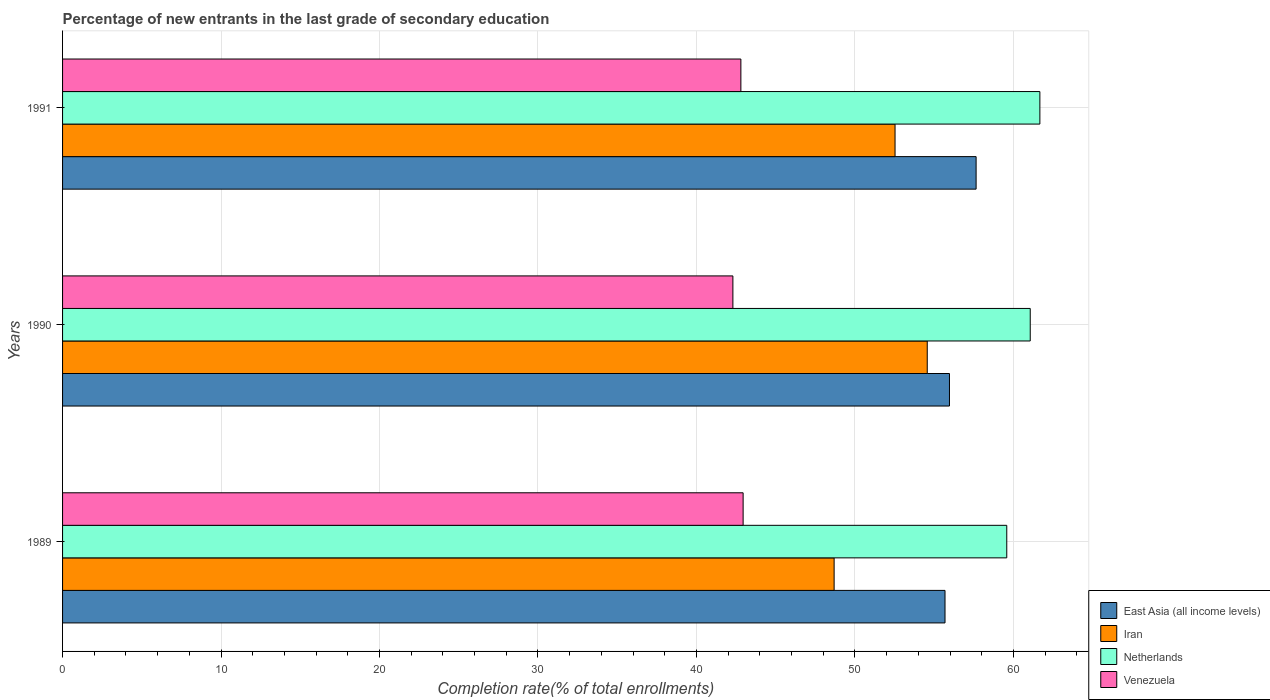How many groups of bars are there?
Your answer should be compact. 3. Are the number of bars per tick equal to the number of legend labels?
Make the answer very short. Yes. How many bars are there on the 3rd tick from the top?
Your answer should be compact. 4. How many bars are there on the 2nd tick from the bottom?
Keep it short and to the point. 4. In how many cases, is the number of bars for a given year not equal to the number of legend labels?
Offer a very short reply. 0. What is the percentage of new entrants in Iran in 1990?
Your answer should be compact. 54.56. Across all years, what is the maximum percentage of new entrants in Netherlands?
Your response must be concise. 61.67. Across all years, what is the minimum percentage of new entrants in Netherlands?
Keep it short and to the point. 59.58. In which year was the percentage of new entrants in Netherlands maximum?
Your answer should be compact. 1991. In which year was the percentage of new entrants in Iran minimum?
Provide a short and direct response. 1989. What is the total percentage of new entrants in East Asia (all income levels) in the graph?
Ensure brevity in your answer.  169.3. What is the difference between the percentage of new entrants in Venezuela in 1989 and that in 1990?
Keep it short and to the point. 0.65. What is the difference between the percentage of new entrants in Netherlands in 1990 and the percentage of new entrants in Venezuela in 1989?
Give a very brief answer. 18.12. What is the average percentage of new entrants in East Asia (all income levels) per year?
Your response must be concise. 56.43. In the year 1990, what is the difference between the percentage of new entrants in Netherlands and percentage of new entrants in East Asia (all income levels)?
Your answer should be very brief. 5.1. In how many years, is the percentage of new entrants in Netherlands greater than 22 %?
Ensure brevity in your answer.  3. What is the ratio of the percentage of new entrants in Venezuela in 1989 to that in 1990?
Provide a succinct answer. 1.02. Is the difference between the percentage of new entrants in Netherlands in 1989 and 1990 greater than the difference between the percentage of new entrants in East Asia (all income levels) in 1989 and 1990?
Your answer should be very brief. No. What is the difference between the highest and the second highest percentage of new entrants in Netherlands?
Provide a succinct answer. 0.61. What is the difference between the highest and the lowest percentage of new entrants in Iran?
Ensure brevity in your answer.  5.88. What does the 3rd bar from the top in 1990 represents?
Give a very brief answer. Iran. What does the 1st bar from the bottom in 1991 represents?
Offer a very short reply. East Asia (all income levels). Is it the case that in every year, the sum of the percentage of new entrants in East Asia (all income levels) and percentage of new entrants in Netherlands is greater than the percentage of new entrants in Iran?
Provide a short and direct response. Yes. Are all the bars in the graph horizontal?
Provide a succinct answer. Yes. How many years are there in the graph?
Make the answer very short. 3. Are the values on the major ticks of X-axis written in scientific E-notation?
Offer a very short reply. No. How many legend labels are there?
Your answer should be very brief. 4. What is the title of the graph?
Your response must be concise. Percentage of new entrants in the last grade of secondary education. What is the label or title of the X-axis?
Provide a short and direct response. Completion rate(% of total enrollments). What is the Completion rate(% of total enrollments) of East Asia (all income levels) in 1989?
Ensure brevity in your answer.  55.68. What is the Completion rate(% of total enrollments) in Iran in 1989?
Provide a succinct answer. 48.69. What is the Completion rate(% of total enrollments) of Netherlands in 1989?
Offer a very short reply. 59.58. What is the Completion rate(% of total enrollments) in Venezuela in 1989?
Keep it short and to the point. 42.94. What is the Completion rate(% of total enrollments) in East Asia (all income levels) in 1990?
Your answer should be very brief. 55.97. What is the Completion rate(% of total enrollments) of Iran in 1990?
Offer a very short reply. 54.56. What is the Completion rate(% of total enrollments) of Netherlands in 1990?
Provide a short and direct response. 61.06. What is the Completion rate(% of total enrollments) in Venezuela in 1990?
Your response must be concise. 42.3. What is the Completion rate(% of total enrollments) of East Asia (all income levels) in 1991?
Give a very brief answer. 57.65. What is the Completion rate(% of total enrollments) of Iran in 1991?
Keep it short and to the point. 52.53. What is the Completion rate(% of total enrollments) in Netherlands in 1991?
Make the answer very short. 61.67. What is the Completion rate(% of total enrollments) of Venezuela in 1991?
Your response must be concise. 42.8. Across all years, what is the maximum Completion rate(% of total enrollments) in East Asia (all income levels)?
Your answer should be compact. 57.65. Across all years, what is the maximum Completion rate(% of total enrollments) of Iran?
Give a very brief answer. 54.56. Across all years, what is the maximum Completion rate(% of total enrollments) of Netherlands?
Offer a terse response. 61.67. Across all years, what is the maximum Completion rate(% of total enrollments) of Venezuela?
Give a very brief answer. 42.94. Across all years, what is the minimum Completion rate(% of total enrollments) in East Asia (all income levels)?
Your answer should be very brief. 55.68. Across all years, what is the minimum Completion rate(% of total enrollments) in Iran?
Provide a succinct answer. 48.69. Across all years, what is the minimum Completion rate(% of total enrollments) of Netherlands?
Give a very brief answer. 59.58. Across all years, what is the minimum Completion rate(% of total enrollments) in Venezuela?
Ensure brevity in your answer.  42.3. What is the total Completion rate(% of total enrollments) of East Asia (all income levels) in the graph?
Your answer should be very brief. 169.3. What is the total Completion rate(% of total enrollments) of Iran in the graph?
Ensure brevity in your answer.  155.78. What is the total Completion rate(% of total enrollments) in Netherlands in the graph?
Keep it short and to the point. 182.31. What is the total Completion rate(% of total enrollments) in Venezuela in the graph?
Your response must be concise. 128.05. What is the difference between the Completion rate(% of total enrollments) of East Asia (all income levels) in 1989 and that in 1990?
Provide a short and direct response. -0.28. What is the difference between the Completion rate(% of total enrollments) of Iran in 1989 and that in 1990?
Your response must be concise. -5.88. What is the difference between the Completion rate(% of total enrollments) in Netherlands in 1989 and that in 1990?
Provide a succinct answer. -1.48. What is the difference between the Completion rate(% of total enrollments) in Venezuela in 1989 and that in 1990?
Make the answer very short. 0.65. What is the difference between the Completion rate(% of total enrollments) of East Asia (all income levels) in 1989 and that in 1991?
Your answer should be very brief. -1.96. What is the difference between the Completion rate(% of total enrollments) in Iran in 1989 and that in 1991?
Give a very brief answer. -3.84. What is the difference between the Completion rate(% of total enrollments) of Netherlands in 1989 and that in 1991?
Offer a terse response. -2.09. What is the difference between the Completion rate(% of total enrollments) in Venezuela in 1989 and that in 1991?
Offer a very short reply. 0.14. What is the difference between the Completion rate(% of total enrollments) of East Asia (all income levels) in 1990 and that in 1991?
Give a very brief answer. -1.68. What is the difference between the Completion rate(% of total enrollments) of Iran in 1990 and that in 1991?
Provide a short and direct response. 2.03. What is the difference between the Completion rate(% of total enrollments) in Netherlands in 1990 and that in 1991?
Make the answer very short. -0.61. What is the difference between the Completion rate(% of total enrollments) of Venezuela in 1990 and that in 1991?
Ensure brevity in your answer.  -0.5. What is the difference between the Completion rate(% of total enrollments) of East Asia (all income levels) in 1989 and the Completion rate(% of total enrollments) of Iran in 1990?
Your answer should be compact. 1.12. What is the difference between the Completion rate(% of total enrollments) in East Asia (all income levels) in 1989 and the Completion rate(% of total enrollments) in Netherlands in 1990?
Your answer should be compact. -5.38. What is the difference between the Completion rate(% of total enrollments) of East Asia (all income levels) in 1989 and the Completion rate(% of total enrollments) of Venezuela in 1990?
Make the answer very short. 13.39. What is the difference between the Completion rate(% of total enrollments) of Iran in 1989 and the Completion rate(% of total enrollments) of Netherlands in 1990?
Offer a terse response. -12.37. What is the difference between the Completion rate(% of total enrollments) in Iran in 1989 and the Completion rate(% of total enrollments) in Venezuela in 1990?
Ensure brevity in your answer.  6.39. What is the difference between the Completion rate(% of total enrollments) in Netherlands in 1989 and the Completion rate(% of total enrollments) in Venezuela in 1990?
Your response must be concise. 17.28. What is the difference between the Completion rate(% of total enrollments) in East Asia (all income levels) in 1989 and the Completion rate(% of total enrollments) in Iran in 1991?
Give a very brief answer. 3.15. What is the difference between the Completion rate(% of total enrollments) in East Asia (all income levels) in 1989 and the Completion rate(% of total enrollments) in Netherlands in 1991?
Give a very brief answer. -5.99. What is the difference between the Completion rate(% of total enrollments) of East Asia (all income levels) in 1989 and the Completion rate(% of total enrollments) of Venezuela in 1991?
Offer a very short reply. 12.88. What is the difference between the Completion rate(% of total enrollments) of Iran in 1989 and the Completion rate(% of total enrollments) of Netherlands in 1991?
Provide a succinct answer. -12.98. What is the difference between the Completion rate(% of total enrollments) of Iran in 1989 and the Completion rate(% of total enrollments) of Venezuela in 1991?
Keep it short and to the point. 5.88. What is the difference between the Completion rate(% of total enrollments) in Netherlands in 1989 and the Completion rate(% of total enrollments) in Venezuela in 1991?
Offer a terse response. 16.78. What is the difference between the Completion rate(% of total enrollments) in East Asia (all income levels) in 1990 and the Completion rate(% of total enrollments) in Iran in 1991?
Offer a terse response. 3.43. What is the difference between the Completion rate(% of total enrollments) of East Asia (all income levels) in 1990 and the Completion rate(% of total enrollments) of Netherlands in 1991?
Offer a terse response. -5.71. What is the difference between the Completion rate(% of total enrollments) in East Asia (all income levels) in 1990 and the Completion rate(% of total enrollments) in Venezuela in 1991?
Keep it short and to the point. 13.16. What is the difference between the Completion rate(% of total enrollments) in Iran in 1990 and the Completion rate(% of total enrollments) in Netherlands in 1991?
Provide a short and direct response. -7.11. What is the difference between the Completion rate(% of total enrollments) in Iran in 1990 and the Completion rate(% of total enrollments) in Venezuela in 1991?
Offer a terse response. 11.76. What is the difference between the Completion rate(% of total enrollments) of Netherlands in 1990 and the Completion rate(% of total enrollments) of Venezuela in 1991?
Offer a very short reply. 18.26. What is the average Completion rate(% of total enrollments) in East Asia (all income levels) per year?
Give a very brief answer. 56.43. What is the average Completion rate(% of total enrollments) of Iran per year?
Offer a terse response. 51.93. What is the average Completion rate(% of total enrollments) in Netherlands per year?
Ensure brevity in your answer.  60.77. What is the average Completion rate(% of total enrollments) of Venezuela per year?
Your answer should be compact. 42.68. In the year 1989, what is the difference between the Completion rate(% of total enrollments) of East Asia (all income levels) and Completion rate(% of total enrollments) of Iran?
Keep it short and to the point. 7. In the year 1989, what is the difference between the Completion rate(% of total enrollments) in East Asia (all income levels) and Completion rate(% of total enrollments) in Netherlands?
Your answer should be compact. -3.9. In the year 1989, what is the difference between the Completion rate(% of total enrollments) of East Asia (all income levels) and Completion rate(% of total enrollments) of Venezuela?
Provide a short and direct response. 12.74. In the year 1989, what is the difference between the Completion rate(% of total enrollments) in Iran and Completion rate(% of total enrollments) in Netherlands?
Your answer should be very brief. -10.89. In the year 1989, what is the difference between the Completion rate(% of total enrollments) in Iran and Completion rate(% of total enrollments) in Venezuela?
Make the answer very short. 5.74. In the year 1989, what is the difference between the Completion rate(% of total enrollments) of Netherlands and Completion rate(% of total enrollments) of Venezuela?
Offer a terse response. 16.64. In the year 1990, what is the difference between the Completion rate(% of total enrollments) of East Asia (all income levels) and Completion rate(% of total enrollments) of Iran?
Ensure brevity in your answer.  1.4. In the year 1990, what is the difference between the Completion rate(% of total enrollments) of East Asia (all income levels) and Completion rate(% of total enrollments) of Netherlands?
Provide a short and direct response. -5.1. In the year 1990, what is the difference between the Completion rate(% of total enrollments) in East Asia (all income levels) and Completion rate(% of total enrollments) in Venezuela?
Make the answer very short. 13.67. In the year 1990, what is the difference between the Completion rate(% of total enrollments) of Iran and Completion rate(% of total enrollments) of Netherlands?
Offer a terse response. -6.5. In the year 1990, what is the difference between the Completion rate(% of total enrollments) in Iran and Completion rate(% of total enrollments) in Venezuela?
Your response must be concise. 12.26. In the year 1990, what is the difference between the Completion rate(% of total enrollments) in Netherlands and Completion rate(% of total enrollments) in Venezuela?
Your response must be concise. 18.76. In the year 1991, what is the difference between the Completion rate(% of total enrollments) in East Asia (all income levels) and Completion rate(% of total enrollments) in Iran?
Keep it short and to the point. 5.11. In the year 1991, what is the difference between the Completion rate(% of total enrollments) in East Asia (all income levels) and Completion rate(% of total enrollments) in Netherlands?
Ensure brevity in your answer.  -4.02. In the year 1991, what is the difference between the Completion rate(% of total enrollments) of East Asia (all income levels) and Completion rate(% of total enrollments) of Venezuela?
Your answer should be very brief. 14.84. In the year 1991, what is the difference between the Completion rate(% of total enrollments) of Iran and Completion rate(% of total enrollments) of Netherlands?
Offer a very short reply. -9.14. In the year 1991, what is the difference between the Completion rate(% of total enrollments) in Iran and Completion rate(% of total enrollments) in Venezuela?
Provide a short and direct response. 9.73. In the year 1991, what is the difference between the Completion rate(% of total enrollments) in Netherlands and Completion rate(% of total enrollments) in Venezuela?
Give a very brief answer. 18.87. What is the ratio of the Completion rate(% of total enrollments) of East Asia (all income levels) in 1989 to that in 1990?
Offer a very short reply. 0.99. What is the ratio of the Completion rate(% of total enrollments) in Iran in 1989 to that in 1990?
Your answer should be compact. 0.89. What is the ratio of the Completion rate(% of total enrollments) in Netherlands in 1989 to that in 1990?
Your answer should be very brief. 0.98. What is the ratio of the Completion rate(% of total enrollments) of Venezuela in 1989 to that in 1990?
Keep it short and to the point. 1.02. What is the ratio of the Completion rate(% of total enrollments) in Iran in 1989 to that in 1991?
Provide a succinct answer. 0.93. What is the ratio of the Completion rate(% of total enrollments) of Netherlands in 1989 to that in 1991?
Your answer should be compact. 0.97. What is the ratio of the Completion rate(% of total enrollments) of Venezuela in 1989 to that in 1991?
Keep it short and to the point. 1. What is the ratio of the Completion rate(% of total enrollments) of East Asia (all income levels) in 1990 to that in 1991?
Make the answer very short. 0.97. What is the ratio of the Completion rate(% of total enrollments) of Iran in 1990 to that in 1991?
Provide a short and direct response. 1.04. What is the ratio of the Completion rate(% of total enrollments) in Netherlands in 1990 to that in 1991?
Provide a succinct answer. 0.99. What is the difference between the highest and the second highest Completion rate(% of total enrollments) of East Asia (all income levels)?
Make the answer very short. 1.68. What is the difference between the highest and the second highest Completion rate(% of total enrollments) of Iran?
Give a very brief answer. 2.03. What is the difference between the highest and the second highest Completion rate(% of total enrollments) in Netherlands?
Your response must be concise. 0.61. What is the difference between the highest and the second highest Completion rate(% of total enrollments) of Venezuela?
Your answer should be very brief. 0.14. What is the difference between the highest and the lowest Completion rate(% of total enrollments) of East Asia (all income levels)?
Keep it short and to the point. 1.96. What is the difference between the highest and the lowest Completion rate(% of total enrollments) in Iran?
Ensure brevity in your answer.  5.88. What is the difference between the highest and the lowest Completion rate(% of total enrollments) of Netherlands?
Provide a short and direct response. 2.09. What is the difference between the highest and the lowest Completion rate(% of total enrollments) in Venezuela?
Give a very brief answer. 0.65. 